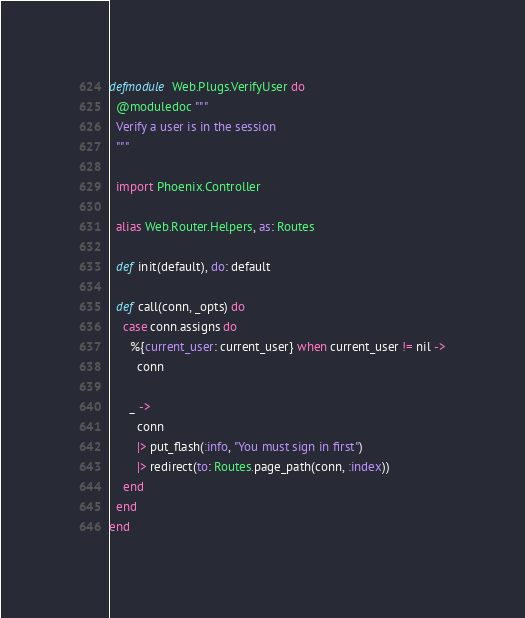Convert code to text. <code><loc_0><loc_0><loc_500><loc_500><_Elixir_>defmodule Web.Plugs.VerifyUser do
  @moduledoc """
  Verify a user is in the session
  """

  import Phoenix.Controller

  alias Web.Router.Helpers, as: Routes

  def init(default), do: default

  def call(conn, _opts) do
    case conn.assigns do
      %{current_user: current_user} when current_user != nil ->
        conn

      _ ->
        conn
        |> put_flash(:info, "You must sign in first")
        |> redirect(to: Routes.page_path(conn, :index))
    end
  end
end
</code> 